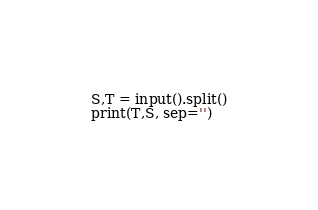Convert code to text. <code><loc_0><loc_0><loc_500><loc_500><_Python_>S,T = input().split()
print(T,S, sep='')</code> 